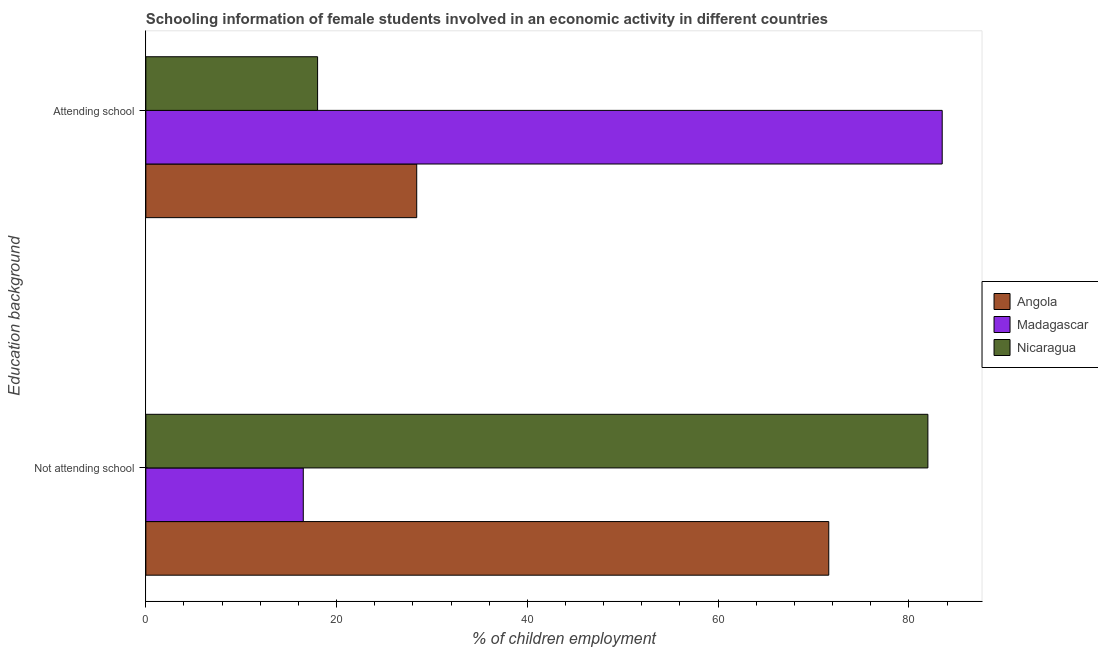Are the number of bars per tick equal to the number of legend labels?
Provide a succinct answer. Yes. Are the number of bars on each tick of the Y-axis equal?
Offer a very short reply. Yes. How many bars are there on the 2nd tick from the top?
Your answer should be compact. 3. What is the label of the 1st group of bars from the top?
Make the answer very short. Attending school. What is the percentage of employed females who are not attending school in Madagascar?
Provide a short and direct response. 16.51. Across all countries, what is the maximum percentage of employed females who are not attending school?
Offer a terse response. 81.99. Across all countries, what is the minimum percentage of employed females who are attending school?
Provide a short and direct response. 18.01. In which country was the percentage of employed females who are not attending school maximum?
Your answer should be very brief. Nicaragua. In which country was the percentage of employed females who are attending school minimum?
Offer a terse response. Nicaragua. What is the total percentage of employed females who are attending school in the graph?
Give a very brief answer. 129.9. What is the difference between the percentage of employed females who are attending school in Angola and that in Madagascar?
Your response must be concise. -55.09. What is the difference between the percentage of employed females who are not attending school in Nicaragua and the percentage of employed females who are attending school in Angola?
Your response must be concise. 53.59. What is the average percentage of employed females who are attending school per country?
Offer a terse response. 43.3. What is the difference between the percentage of employed females who are not attending school and percentage of employed females who are attending school in Madagascar?
Keep it short and to the point. -66.99. In how many countries, is the percentage of employed females who are not attending school greater than 16 %?
Make the answer very short. 3. What is the ratio of the percentage of employed females who are attending school in Angola to that in Nicaragua?
Provide a short and direct response. 1.58. Is the percentage of employed females who are not attending school in Angola less than that in Madagascar?
Ensure brevity in your answer.  No. What does the 1st bar from the top in Attending school represents?
Give a very brief answer. Nicaragua. What does the 3rd bar from the bottom in Not attending school represents?
Keep it short and to the point. Nicaragua. Are all the bars in the graph horizontal?
Offer a terse response. Yes. How many countries are there in the graph?
Make the answer very short. 3. What is the difference between two consecutive major ticks on the X-axis?
Your response must be concise. 20. Are the values on the major ticks of X-axis written in scientific E-notation?
Offer a very short reply. No. Does the graph contain any zero values?
Your response must be concise. No. What is the title of the graph?
Ensure brevity in your answer.  Schooling information of female students involved in an economic activity in different countries. What is the label or title of the X-axis?
Offer a very short reply. % of children employment. What is the label or title of the Y-axis?
Ensure brevity in your answer.  Education background. What is the % of children employment in Angola in Not attending school?
Offer a terse response. 71.6. What is the % of children employment in Madagascar in Not attending school?
Provide a short and direct response. 16.51. What is the % of children employment of Nicaragua in Not attending school?
Your answer should be very brief. 81.99. What is the % of children employment in Angola in Attending school?
Ensure brevity in your answer.  28.4. What is the % of children employment in Madagascar in Attending school?
Offer a terse response. 83.49. What is the % of children employment in Nicaragua in Attending school?
Ensure brevity in your answer.  18.01. Across all Education background, what is the maximum % of children employment of Angola?
Your response must be concise. 71.6. Across all Education background, what is the maximum % of children employment in Madagascar?
Your answer should be compact. 83.49. Across all Education background, what is the maximum % of children employment of Nicaragua?
Ensure brevity in your answer.  81.99. Across all Education background, what is the minimum % of children employment in Angola?
Your answer should be very brief. 28.4. Across all Education background, what is the minimum % of children employment in Madagascar?
Offer a terse response. 16.51. Across all Education background, what is the minimum % of children employment in Nicaragua?
Provide a short and direct response. 18.01. What is the total % of children employment of Angola in the graph?
Your answer should be compact. 100. What is the difference between the % of children employment in Angola in Not attending school and that in Attending school?
Provide a succinct answer. 43.2. What is the difference between the % of children employment of Madagascar in Not attending school and that in Attending school?
Your response must be concise. -66.99. What is the difference between the % of children employment of Nicaragua in Not attending school and that in Attending school?
Provide a short and direct response. 63.99. What is the difference between the % of children employment in Angola in Not attending school and the % of children employment in Madagascar in Attending school?
Provide a succinct answer. -11.89. What is the difference between the % of children employment of Angola in Not attending school and the % of children employment of Nicaragua in Attending school?
Ensure brevity in your answer.  53.59. What is the difference between the % of children employment in Madagascar in Not attending school and the % of children employment in Nicaragua in Attending school?
Your answer should be very brief. -1.5. What is the average % of children employment in Nicaragua per Education background?
Provide a succinct answer. 50. What is the difference between the % of children employment in Angola and % of children employment in Madagascar in Not attending school?
Your response must be concise. 55.09. What is the difference between the % of children employment in Angola and % of children employment in Nicaragua in Not attending school?
Your response must be concise. -10.39. What is the difference between the % of children employment of Madagascar and % of children employment of Nicaragua in Not attending school?
Your answer should be very brief. -65.49. What is the difference between the % of children employment in Angola and % of children employment in Madagascar in Attending school?
Offer a very short reply. -55.09. What is the difference between the % of children employment in Angola and % of children employment in Nicaragua in Attending school?
Keep it short and to the point. 10.39. What is the difference between the % of children employment of Madagascar and % of children employment of Nicaragua in Attending school?
Make the answer very short. 65.49. What is the ratio of the % of children employment in Angola in Not attending school to that in Attending school?
Ensure brevity in your answer.  2.52. What is the ratio of the % of children employment in Madagascar in Not attending school to that in Attending school?
Your answer should be compact. 0.2. What is the ratio of the % of children employment of Nicaragua in Not attending school to that in Attending school?
Ensure brevity in your answer.  4.55. What is the difference between the highest and the second highest % of children employment in Angola?
Your response must be concise. 43.2. What is the difference between the highest and the second highest % of children employment of Madagascar?
Offer a very short reply. 66.99. What is the difference between the highest and the second highest % of children employment in Nicaragua?
Ensure brevity in your answer.  63.99. What is the difference between the highest and the lowest % of children employment of Angola?
Offer a terse response. 43.2. What is the difference between the highest and the lowest % of children employment in Madagascar?
Offer a very short reply. 66.99. What is the difference between the highest and the lowest % of children employment of Nicaragua?
Provide a succinct answer. 63.99. 